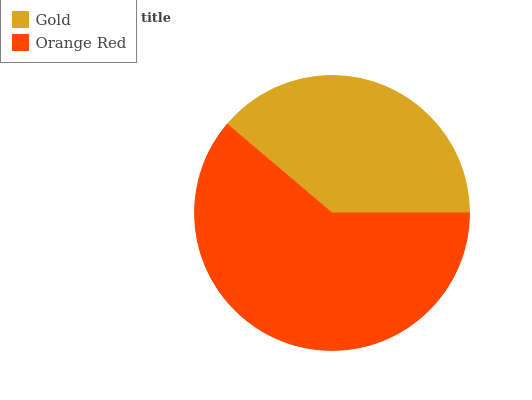Is Gold the minimum?
Answer yes or no. Yes. Is Orange Red the maximum?
Answer yes or no. Yes. Is Orange Red the minimum?
Answer yes or no. No. Is Orange Red greater than Gold?
Answer yes or no. Yes. Is Gold less than Orange Red?
Answer yes or no. Yes. Is Gold greater than Orange Red?
Answer yes or no. No. Is Orange Red less than Gold?
Answer yes or no. No. Is Orange Red the high median?
Answer yes or no. Yes. Is Gold the low median?
Answer yes or no. Yes. Is Gold the high median?
Answer yes or no. No. Is Orange Red the low median?
Answer yes or no. No. 